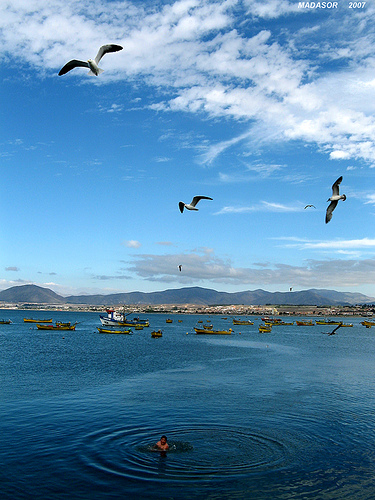What time of day does it appear to be in this scene? The long shadows and the peaceful atmosphere point towards the early morning or late afternoon, a time when the sun is not directly overhead but positioned at an angle that creates a soft, golden light and enhances the serenity of the coastal scenery. 